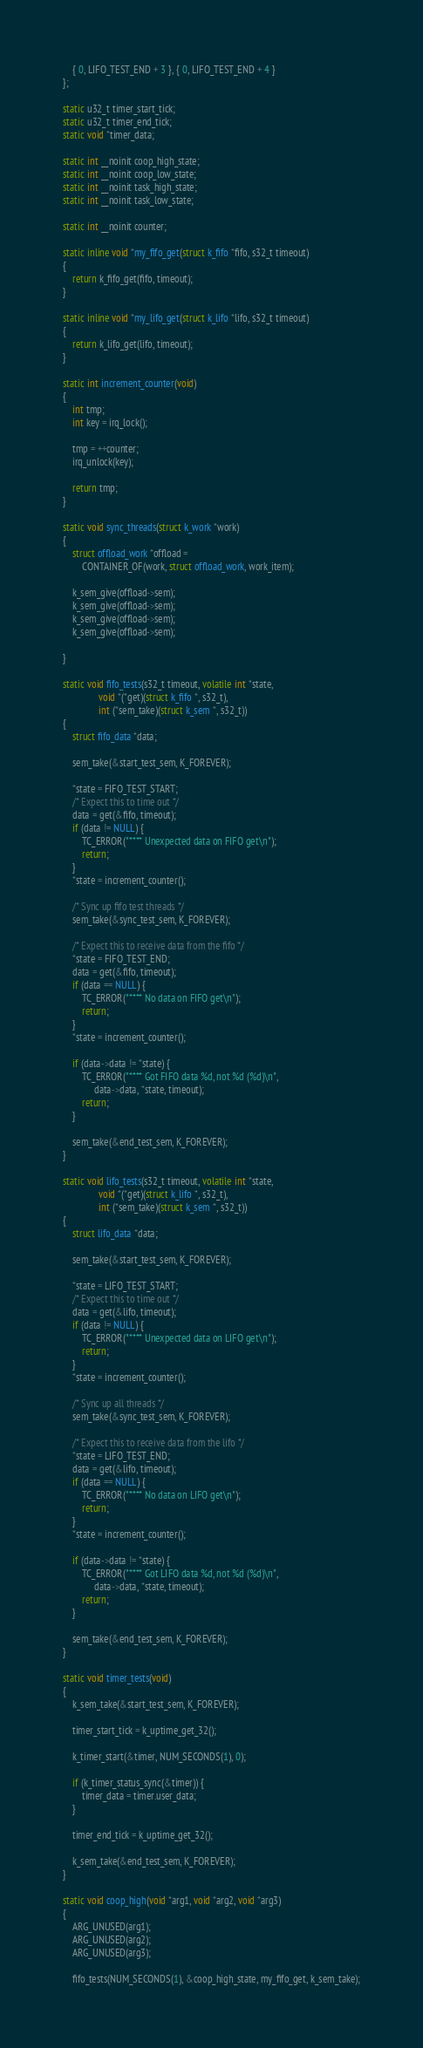Convert code to text. <code><loc_0><loc_0><loc_500><loc_500><_C_>	{ 0, LIFO_TEST_END + 3 }, { 0, LIFO_TEST_END + 4 }
};

static u32_t timer_start_tick;
static u32_t timer_end_tick;
static void *timer_data;

static int __noinit coop_high_state;
static int __noinit coop_low_state;
static int __noinit task_high_state;
static int __noinit task_low_state;

static int __noinit counter;

static inline void *my_fifo_get(struct k_fifo *fifo, s32_t timeout)
{
	return k_fifo_get(fifo, timeout);
}

static inline void *my_lifo_get(struct k_lifo *lifo, s32_t timeout)
{
	return k_lifo_get(lifo, timeout);
}

static int increment_counter(void)
{
	int tmp;
	int key = irq_lock();

	tmp = ++counter;
	irq_unlock(key);

	return tmp;
}

static void sync_threads(struct k_work *work)
{
	struct offload_work *offload =
		CONTAINER_OF(work, struct offload_work, work_item);

	k_sem_give(offload->sem);
	k_sem_give(offload->sem);
	k_sem_give(offload->sem);
	k_sem_give(offload->sem);

}

static void fifo_tests(s32_t timeout, volatile int *state,
		       void *(*get)(struct k_fifo *, s32_t),
		       int (*sem_take)(struct k_sem *, s32_t))
{
	struct fifo_data *data;

	sem_take(&start_test_sem, K_FOREVER);

	*state = FIFO_TEST_START;
	/* Expect this to time out */
	data = get(&fifo, timeout);
	if (data != NULL) {
		TC_ERROR("**** Unexpected data on FIFO get\n");
		return;
	}
	*state = increment_counter();

	/* Sync up fifo test threads */
	sem_take(&sync_test_sem, K_FOREVER);

	/* Expect this to receive data from the fifo */
	*state = FIFO_TEST_END;
	data = get(&fifo, timeout);
	if (data == NULL) {
		TC_ERROR("**** No data on FIFO get\n");
		return;
	}
	*state = increment_counter();

	if (data->data != *state) {
		TC_ERROR("**** Got FIFO data %d, not %d (%d)\n",
			 data->data, *state, timeout);
		return;
	}

	sem_take(&end_test_sem, K_FOREVER);
}

static void lifo_tests(s32_t timeout, volatile int *state,
		       void *(*get)(struct k_lifo *, s32_t),
		       int (*sem_take)(struct k_sem *, s32_t))
{
	struct lifo_data *data;

	sem_take(&start_test_sem, K_FOREVER);

	*state = LIFO_TEST_START;
	/* Expect this to time out */
	data = get(&lifo, timeout);
	if (data != NULL) {
		TC_ERROR("**** Unexpected data on LIFO get\n");
		return;
	}
	*state = increment_counter();

	/* Sync up all threads */
	sem_take(&sync_test_sem, K_FOREVER);

	/* Expect this to receive data from the lifo */
	*state = LIFO_TEST_END;
	data = get(&lifo, timeout);
	if (data == NULL) {
		TC_ERROR("**** No data on LIFO get\n");
		return;
	}
	*state = increment_counter();

	if (data->data != *state) {
		TC_ERROR("**** Got LIFO data %d, not %d (%d)\n",
			 data->data, *state, timeout);
		return;
	}

	sem_take(&end_test_sem, K_FOREVER);
}

static void timer_tests(void)
{
	k_sem_take(&start_test_sem, K_FOREVER);

	timer_start_tick = k_uptime_get_32();

	k_timer_start(&timer, NUM_SECONDS(1), 0);

	if (k_timer_status_sync(&timer)) {
		timer_data = timer.user_data;
	}

	timer_end_tick = k_uptime_get_32();

	k_sem_take(&end_test_sem, K_FOREVER);
}

static void coop_high(void *arg1, void *arg2, void *arg3)
{
	ARG_UNUSED(arg1);
	ARG_UNUSED(arg2);
	ARG_UNUSED(arg3);

	fifo_tests(NUM_SECONDS(1), &coop_high_state, my_fifo_get, k_sem_take);
</code> 